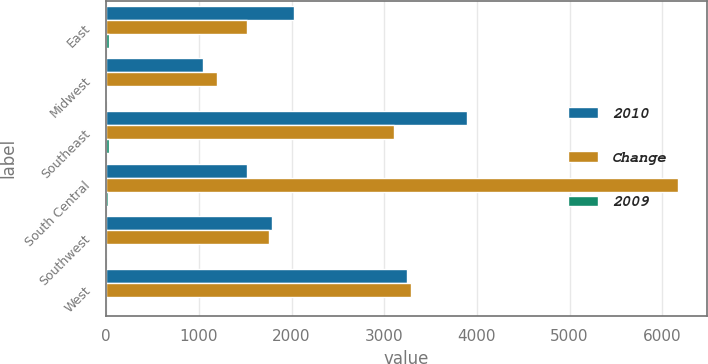Convert chart to OTSL. <chart><loc_0><loc_0><loc_500><loc_500><stacked_bar_chart><ecel><fcel>East<fcel>Midwest<fcel>Southeast<fcel>South Central<fcel>Southwest<fcel>West<nl><fcel>2010<fcel>2027<fcel>1045<fcel>3892<fcel>1519<fcel>1785<fcel>3251<nl><fcel>Change<fcel>1519<fcel>1198<fcel>3107<fcel>6172<fcel>1751<fcel>3287<nl><fcel>2009<fcel>33<fcel>13<fcel>25<fcel>19<fcel>2<fcel>1<nl></chart> 